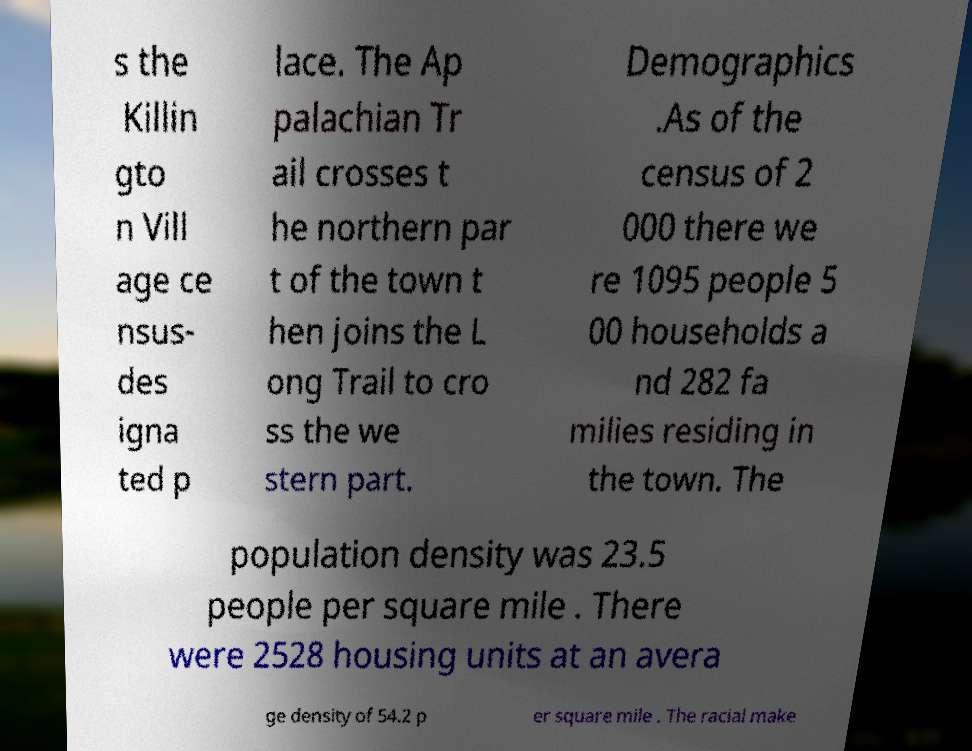For documentation purposes, I need the text within this image transcribed. Could you provide that? s the Killin gto n Vill age ce nsus- des igna ted p lace. The Ap palachian Tr ail crosses t he northern par t of the town t hen joins the L ong Trail to cro ss the we stern part. Demographics .As of the census of 2 000 there we re 1095 people 5 00 households a nd 282 fa milies residing in the town. The population density was 23.5 people per square mile . There were 2528 housing units at an avera ge density of 54.2 p er square mile . The racial make 